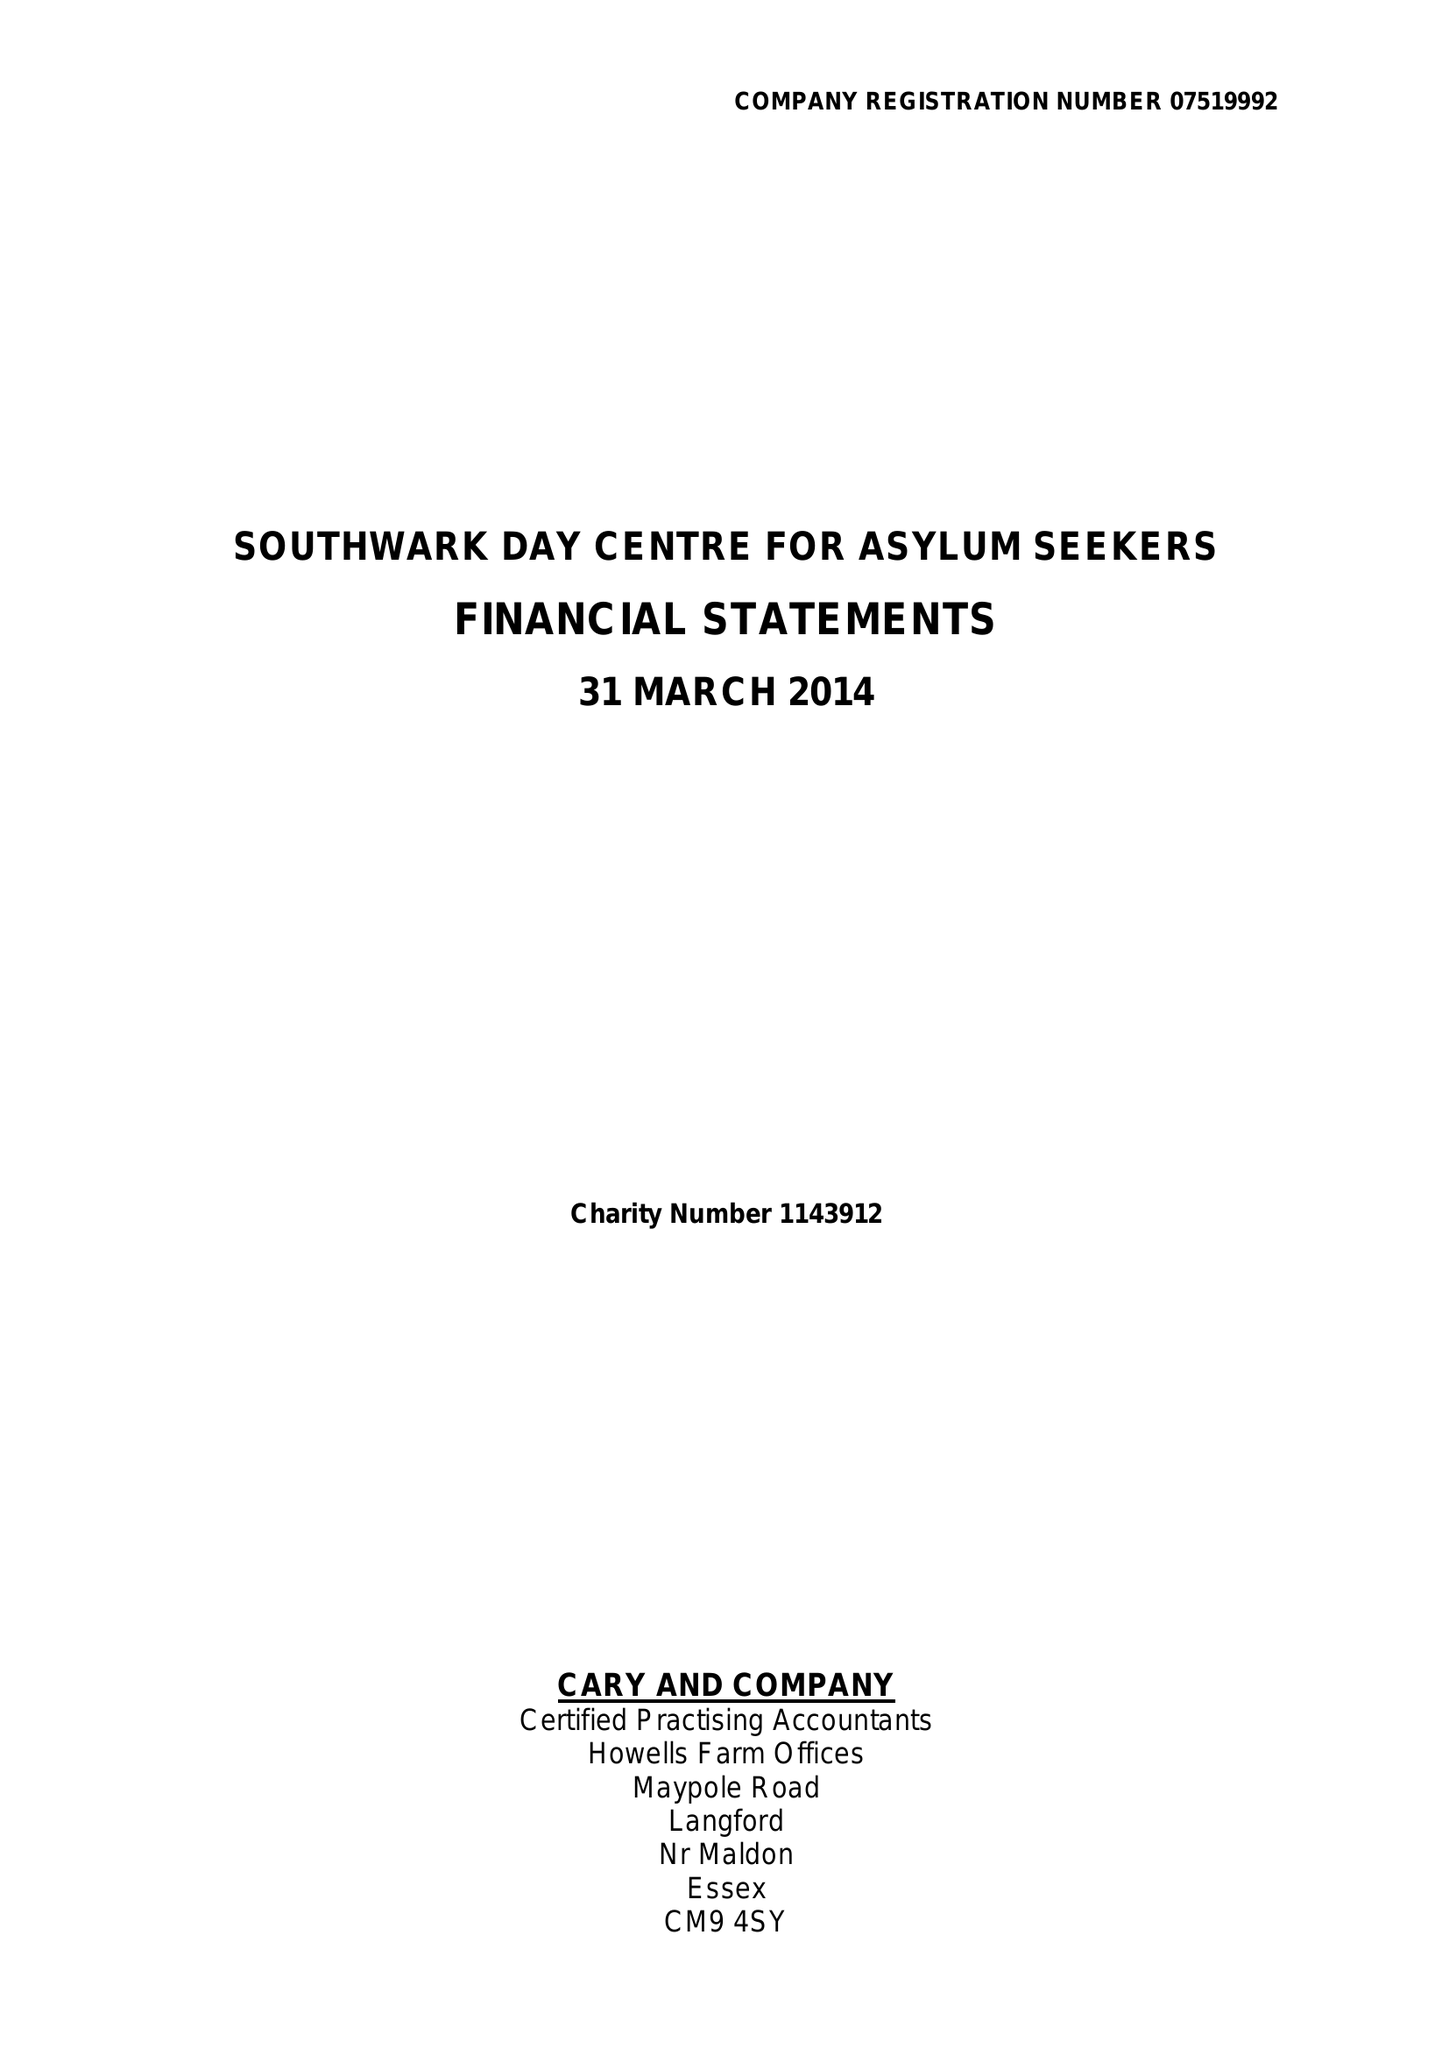What is the value for the address__post_town?
Answer the question using a single word or phrase. LONDON 